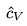Convert formula to latex. <formula><loc_0><loc_0><loc_500><loc_500>\hat { c } _ { V }</formula> 